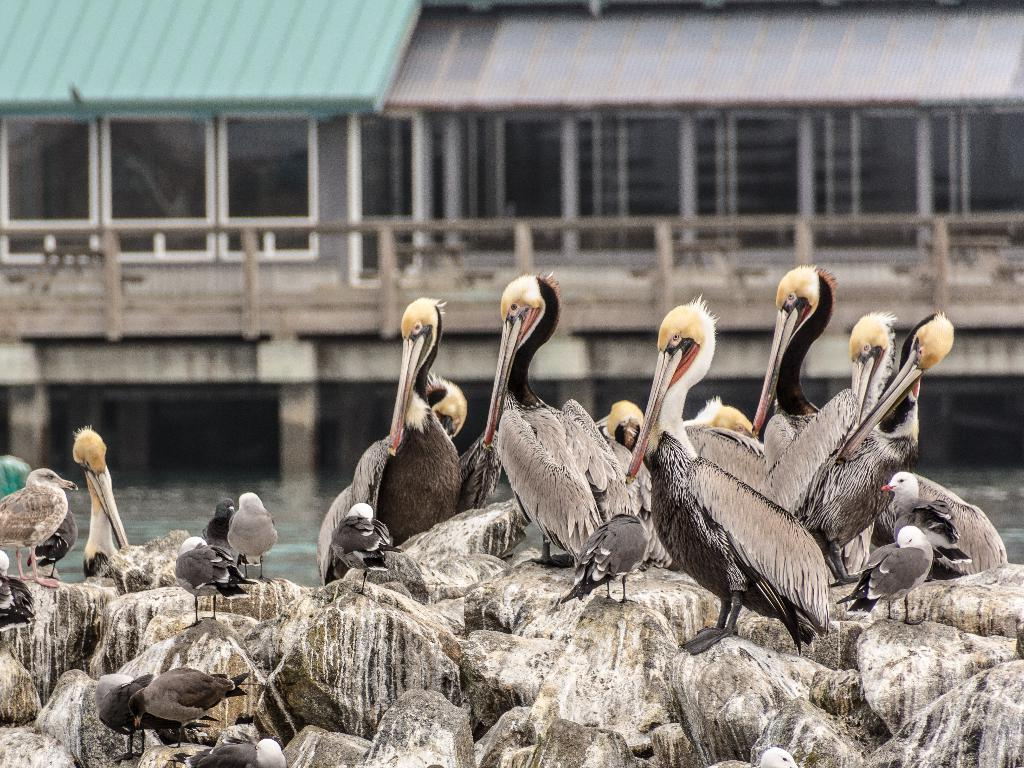What type of animals can be seen in the image? There are birds in the image. Where are the birds located in the image? The birds are sitting on rocks in the image. What body of water is visible in the image? There is a lake in the image. What man-made structure can be seen in the image? There is a bridge in the image. What can be seen in the distance in the image? There are buildings in the background of the image. What type of needle is being used for arithmetic in the image? There is no needle or arithmetic activity present in the image. 